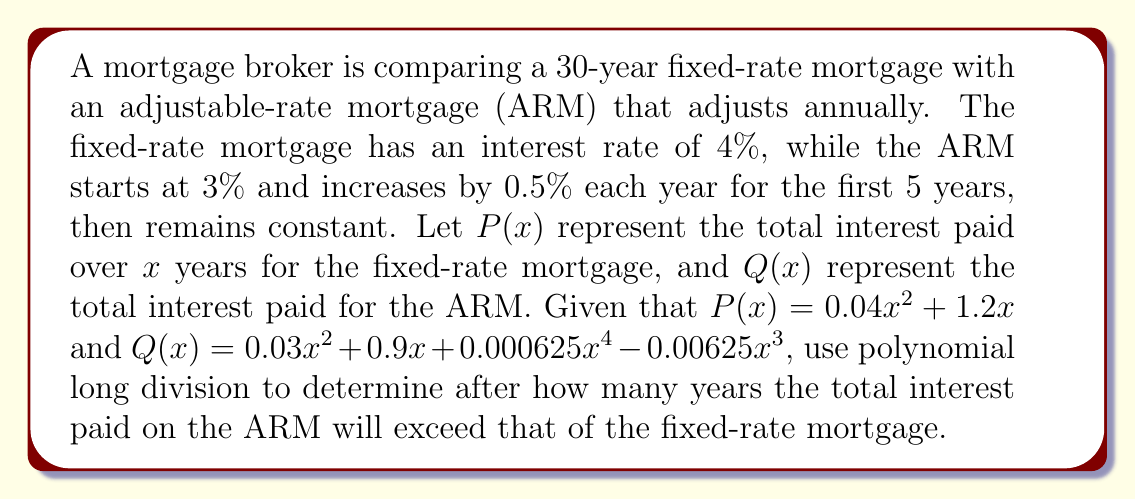Provide a solution to this math problem. To solve this problem, we need to find when $Q(x) - P(x) > 0$. Let's perform polynomial long division:

$Q(x) - P(x) = (0.03x^2 + 0.9x + 0.000625x^4 - 0.00625x^3) - (0.04x^2 + 1.2x)$
$= 0.000625x^4 - 0.00625x^3 - 0.01x^2 - 0.3x$

Now, let's factor out the common factor:

$= 0.000625x(x^3 - 10x^2 - 16x - 480)$

To find the roots, we need to solve:

$x^3 - 10x^2 - 16x - 480 = 0$

This is a cubic equation. We can use the rational root theorem to find potential roots. The factors of 480 are: ±1, ±2, ±3, ±4, ±5, ±6, ±8, ±10, ±12, ±15, ±16, ±20, ±24, ±30, ±40, ±48, ±60, ±80, ±120, ±160, ±240, ±480.

By testing these values, we find that 16 is a root. Dividing the polynomial by $(x - 16)$, we get:

$x^3 - 10x^2 - 16x - 480 = (x - 16)(x^2 + 6x + 30)$

The quadratic $x^2 + 6x + 30$ has no real roots, so 16 is the only real root of the cubic equation.

Therefore, the ARM will have higher total interest paid after 16 years.
Answer: The total interest paid on the ARM will exceed that of the fixed-rate mortgage after 16 years. 